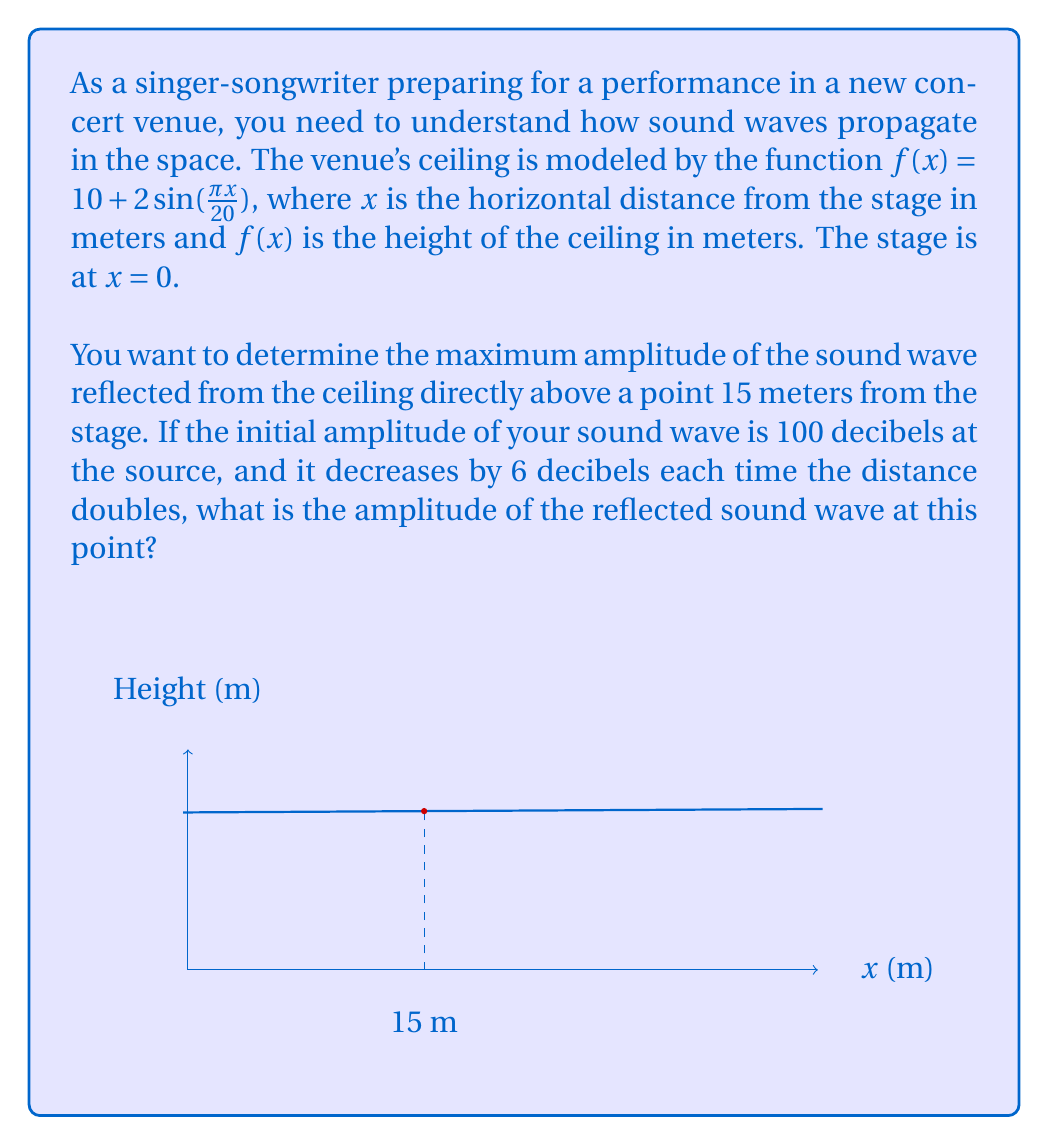Can you solve this math problem? Let's approach this step-by-step:

1) First, we need to find the height of the ceiling at x = 15 m:
   $$f(15) = 10 + 2\sin(\frac{\pi \cdot 15}{20}) = 10 + 2\sin(\frac{3\pi}{4}) = 10 + 2 \cdot \frac{\sqrt{2}}{2} \approx 11.41 \text{ m}$$

2) The sound travels from the stage to the ceiling and then back down, so the total distance it travels is:
   $$d = 15 + 11.41 = 26.41 \text{ m}$$

3) Now, we need to determine how many times the distance has doubled from the initial 1 meter:
   $$2^n = 26.41$$
   $$n = \log_2(26.41) \approx 4.72$$

4) The sound decreases by 6 decibels each time the distance doubles, so the total decrease is:
   $$6 \cdot 4.72 = 28.32 \text{ dB}$$

5) Therefore, the amplitude of the reflected sound wave is:
   $$100 - 28.32 = 71.68 \text{ dB}$$
Answer: 71.68 dB 